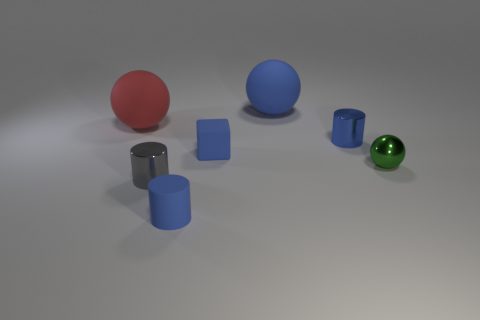Subtract all tiny blue cylinders. How many cylinders are left? 1 Add 3 small gray metallic cylinders. How many objects exist? 10 Subtract all green spheres. How many spheres are left? 2 Subtract 2 spheres. How many spheres are left? 1 Subtract all balls. How many objects are left? 4 Subtract all green cylinders. Subtract all blue balls. How many cylinders are left? 3 Add 2 small metallic cylinders. How many small metallic cylinders are left? 4 Add 5 big brown shiny things. How many big brown shiny things exist? 5 Subtract 0 brown balls. How many objects are left? 7 Subtract all yellow cubes. How many blue cylinders are left? 2 